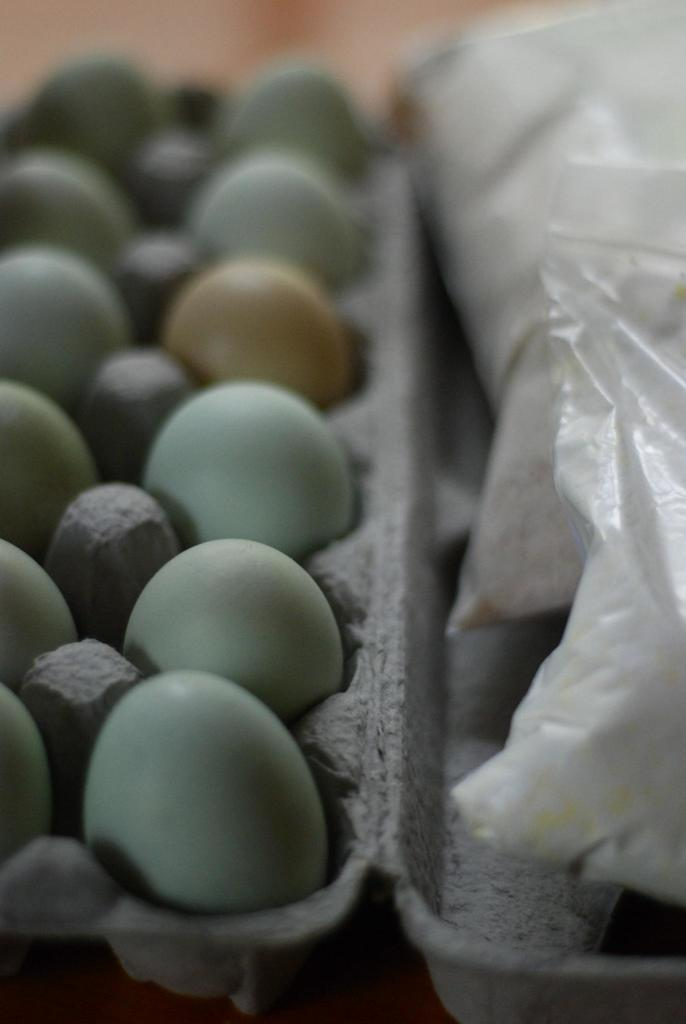What type of food items can be seen in the image? There are eggs and food packets in the image. What is the surface on which the food items are placed? The objects are on a cardboard. How would you describe the background of the image? The background of the image is blurred. What type of line can be seen in the image? There is no line present in the image. 